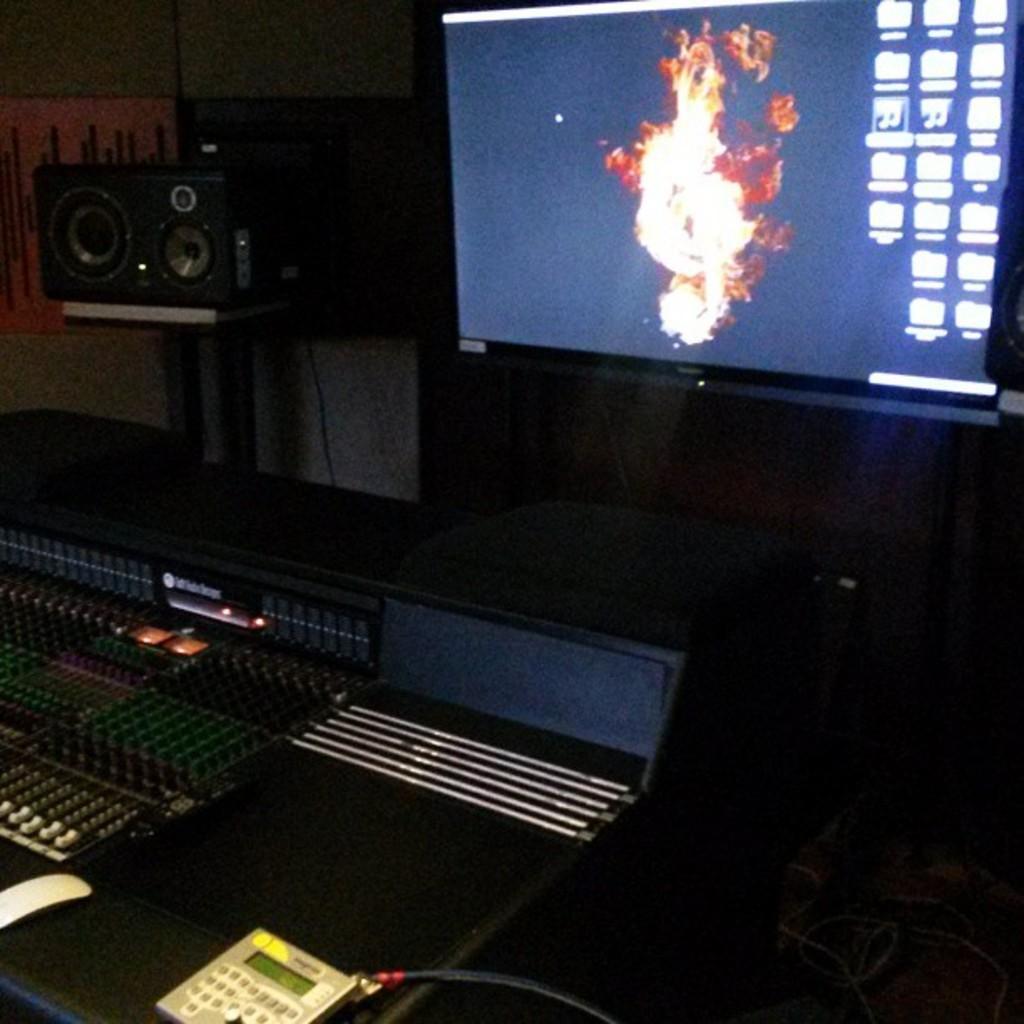In one or two sentences, can you explain what this image depicts? In this image in the center there is one television beside the television there is one speaker, at the bottom there are some sound systems and speakers and some wires. In the background there is a wall. 